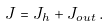Convert formula to latex. <formula><loc_0><loc_0><loc_500><loc_500>J = J _ { h } + J _ { o u t } \, .</formula> 